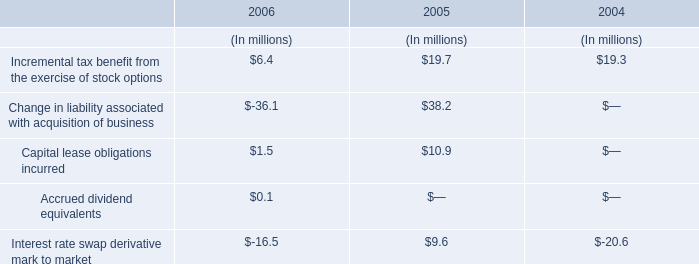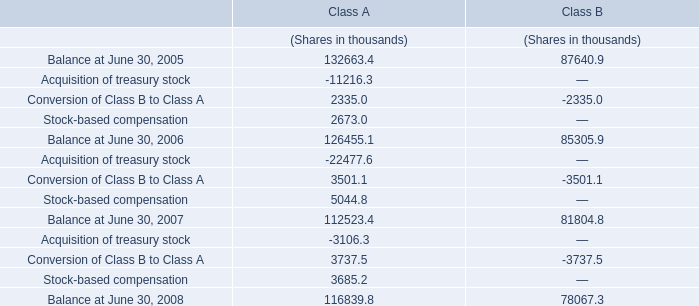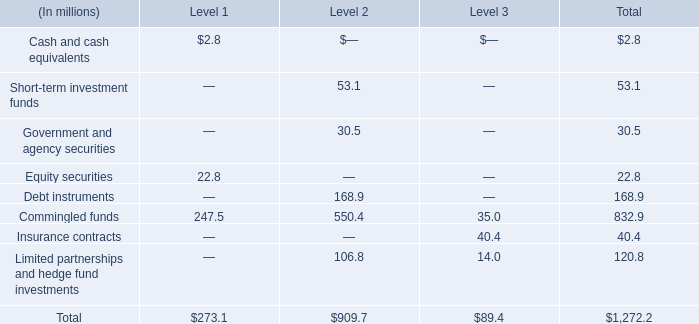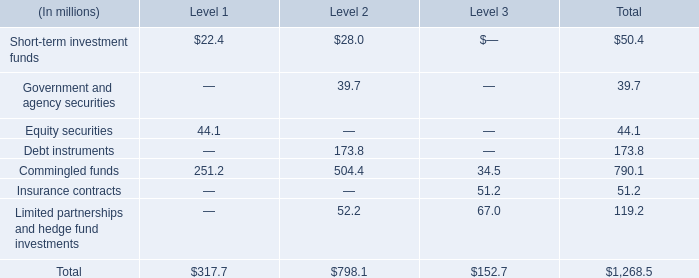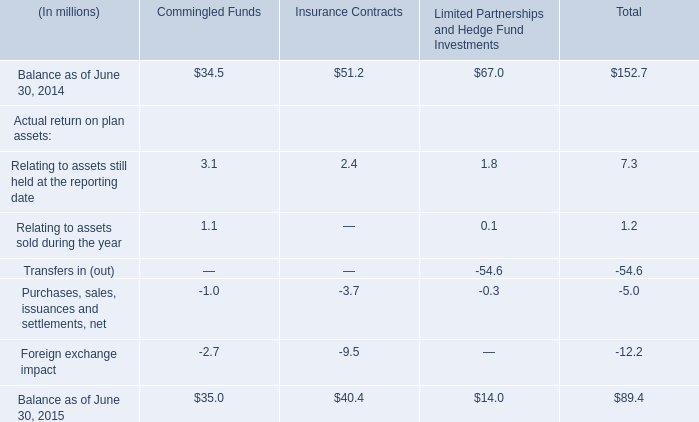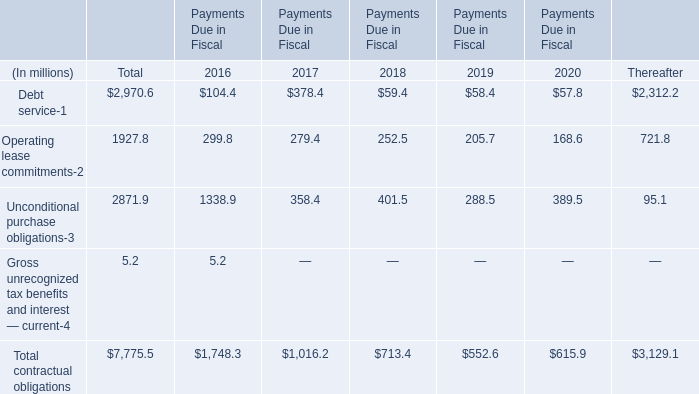What was the total amount of the Government and agency securities in the sections where Commingled funds is greater than 500? (in million) 
Answer: 30.5. 